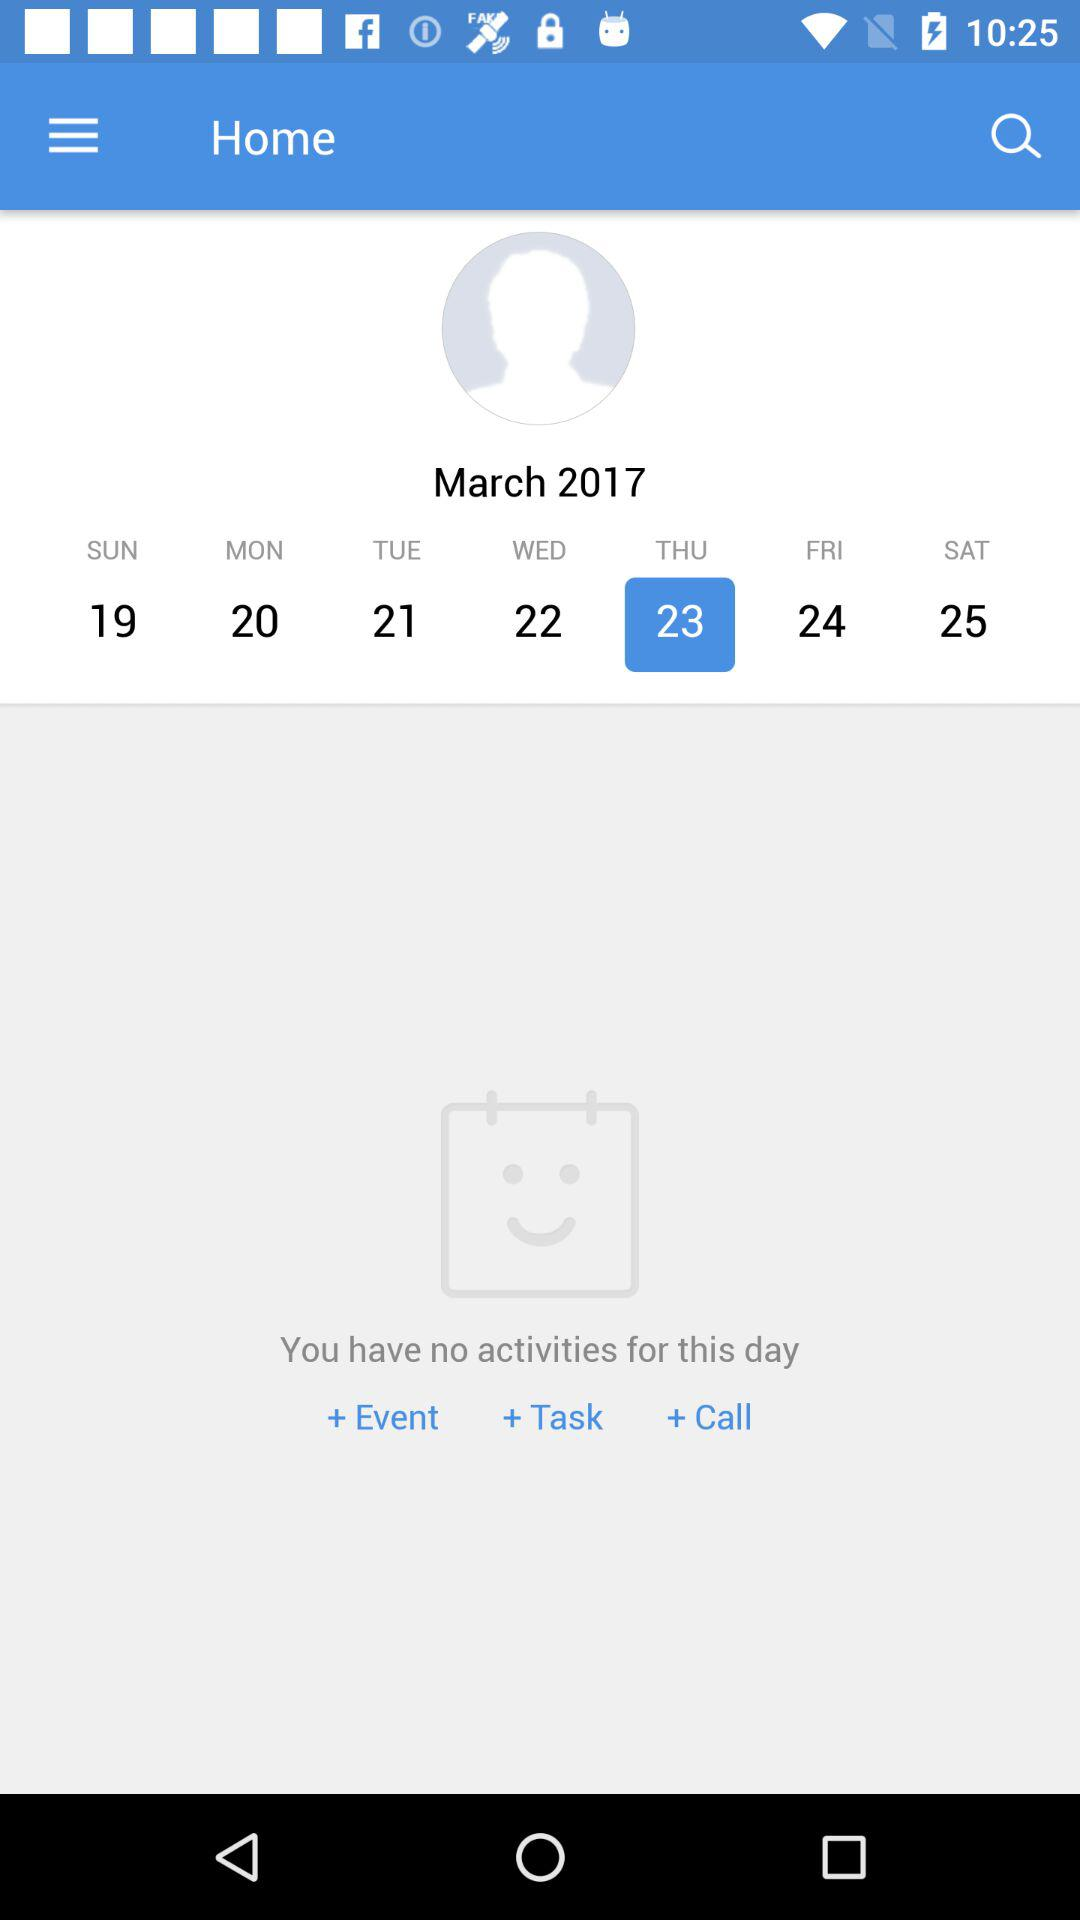What is the month and year? The month is March and the year is 2017. 